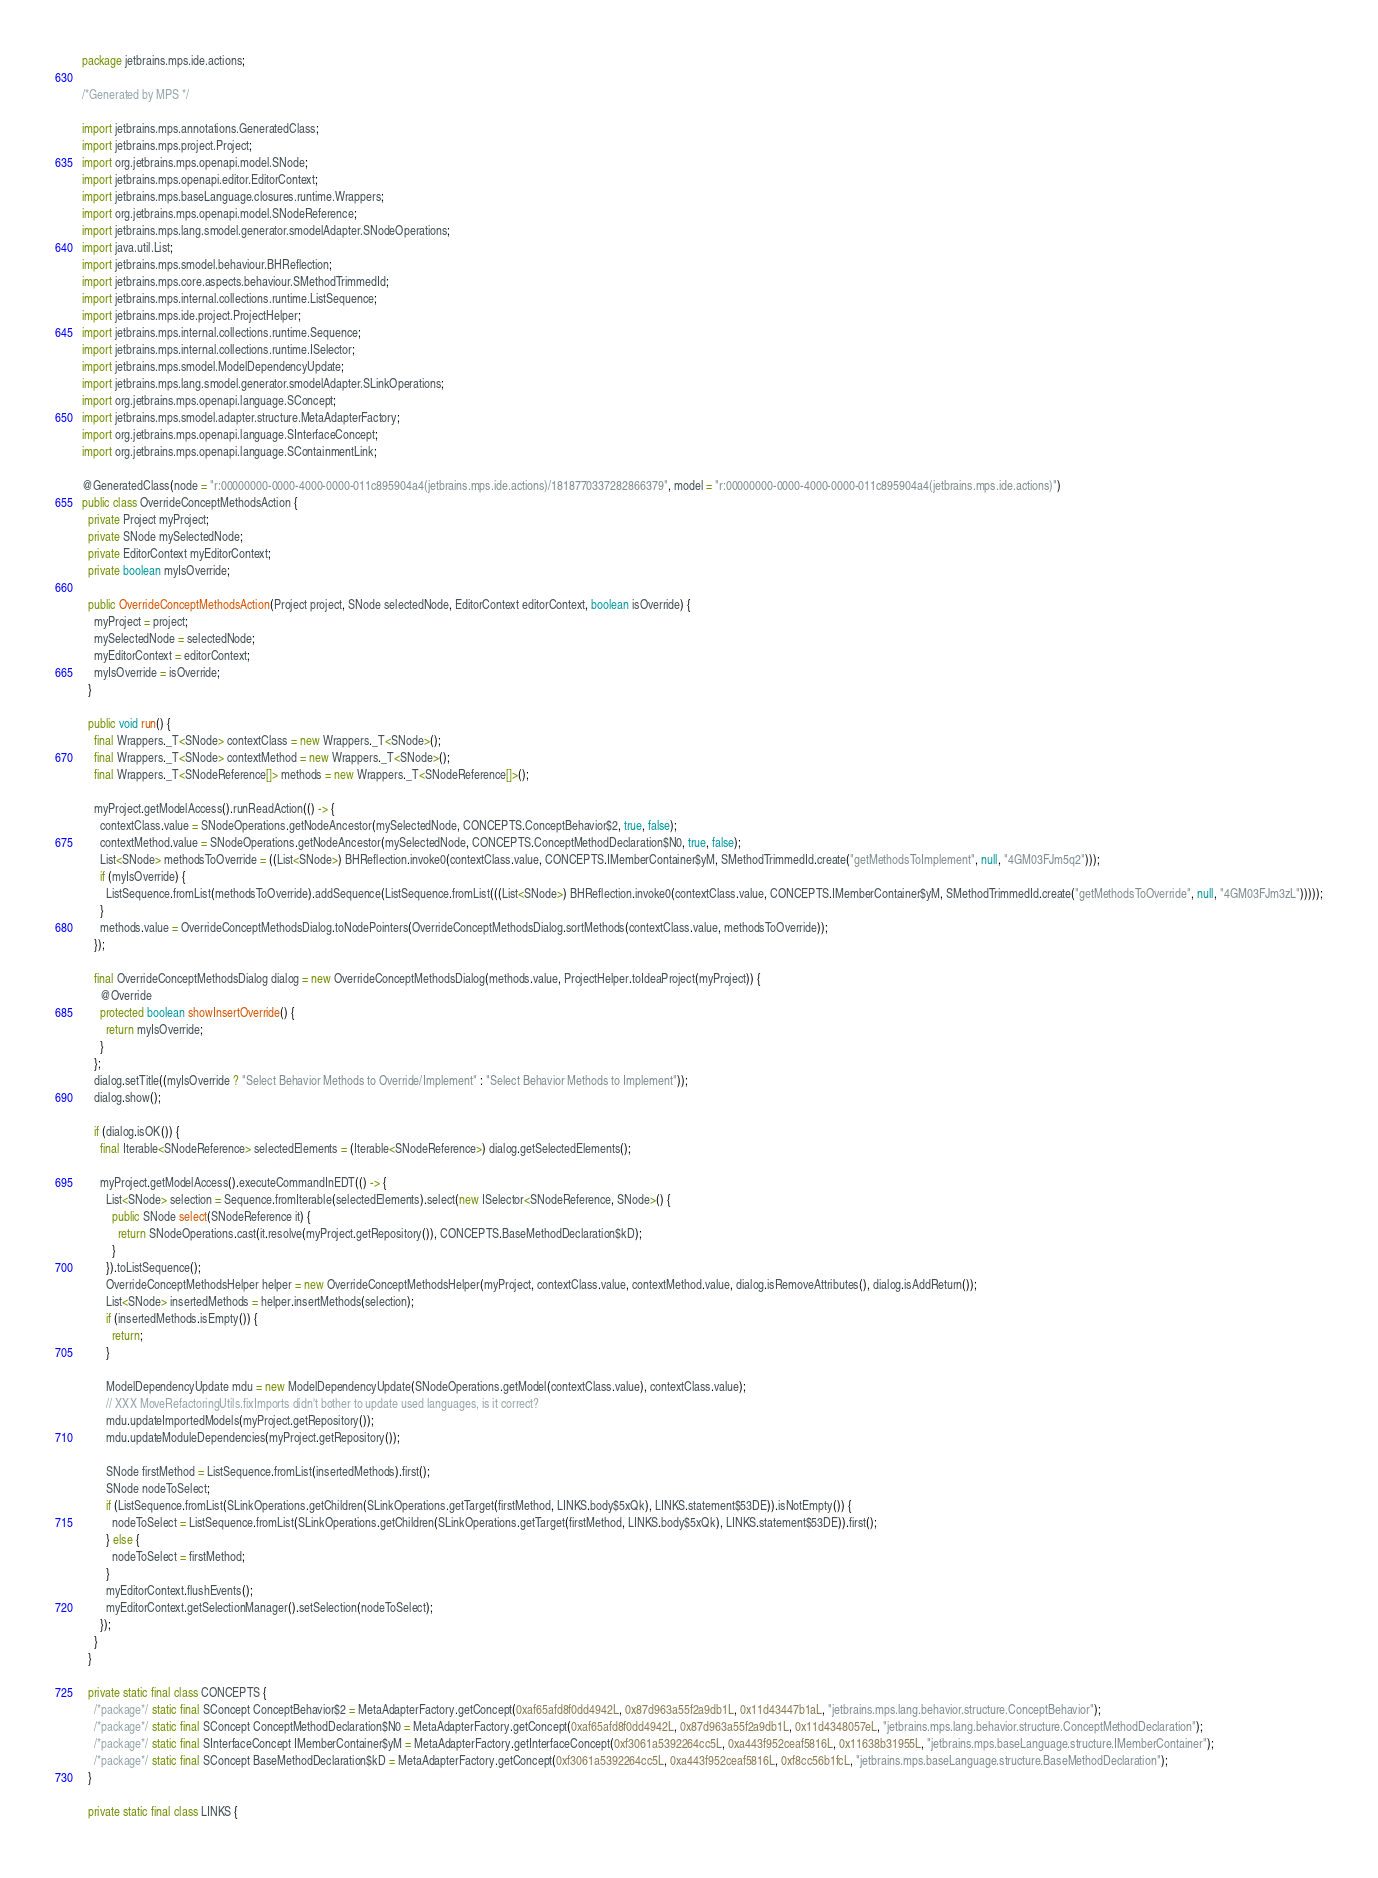Convert code to text. <code><loc_0><loc_0><loc_500><loc_500><_Java_>package jetbrains.mps.ide.actions;

/*Generated by MPS */

import jetbrains.mps.annotations.GeneratedClass;
import jetbrains.mps.project.Project;
import org.jetbrains.mps.openapi.model.SNode;
import jetbrains.mps.openapi.editor.EditorContext;
import jetbrains.mps.baseLanguage.closures.runtime.Wrappers;
import org.jetbrains.mps.openapi.model.SNodeReference;
import jetbrains.mps.lang.smodel.generator.smodelAdapter.SNodeOperations;
import java.util.List;
import jetbrains.mps.smodel.behaviour.BHReflection;
import jetbrains.mps.core.aspects.behaviour.SMethodTrimmedId;
import jetbrains.mps.internal.collections.runtime.ListSequence;
import jetbrains.mps.ide.project.ProjectHelper;
import jetbrains.mps.internal.collections.runtime.Sequence;
import jetbrains.mps.internal.collections.runtime.ISelector;
import jetbrains.mps.smodel.ModelDependencyUpdate;
import jetbrains.mps.lang.smodel.generator.smodelAdapter.SLinkOperations;
import org.jetbrains.mps.openapi.language.SConcept;
import jetbrains.mps.smodel.adapter.structure.MetaAdapterFactory;
import org.jetbrains.mps.openapi.language.SInterfaceConcept;
import org.jetbrains.mps.openapi.language.SContainmentLink;

@GeneratedClass(node = "r:00000000-0000-4000-0000-011c895904a4(jetbrains.mps.ide.actions)/1818770337282866379", model = "r:00000000-0000-4000-0000-011c895904a4(jetbrains.mps.ide.actions)")
public class OverrideConceptMethodsAction {
  private Project myProject;
  private SNode mySelectedNode;
  private EditorContext myEditorContext;
  private boolean myIsOverride;

  public OverrideConceptMethodsAction(Project project, SNode selectedNode, EditorContext editorContext, boolean isOverride) {
    myProject = project;
    mySelectedNode = selectedNode;
    myEditorContext = editorContext;
    myIsOverride = isOverride;
  }

  public void run() {
    final Wrappers._T<SNode> contextClass = new Wrappers._T<SNode>();
    final Wrappers._T<SNode> contextMethod = new Wrappers._T<SNode>();
    final Wrappers._T<SNodeReference[]> methods = new Wrappers._T<SNodeReference[]>();

    myProject.getModelAccess().runReadAction(() -> {
      contextClass.value = SNodeOperations.getNodeAncestor(mySelectedNode, CONCEPTS.ConceptBehavior$2, true, false);
      contextMethod.value = SNodeOperations.getNodeAncestor(mySelectedNode, CONCEPTS.ConceptMethodDeclaration$N0, true, false);
      List<SNode> methodsToOverride = ((List<SNode>) BHReflection.invoke0(contextClass.value, CONCEPTS.IMemberContainer$yM, SMethodTrimmedId.create("getMethodsToImplement", null, "4GM03FJm5q2")));
      if (myIsOverride) {
        ListSequence.fromList(methodsToOverride).addSequence(ListSequence.fromList(((List<SNode>) BHReflection.invoke0(contextClass.value, CONCEPTS.IMemberContainer$yM, SMethodTrimmedId.create("getMethodsToOverride", null, "4GM03FJm3zL")))));
      }
      methods.value = OverrideConceptMethodsDialog.toNodePointers(OverrideConceptMethodsDialog.sortMethods(contextClass.value, methodsToOverride));
    });

    final OverrideConceptMethodsDialog dialog = new OverrideConceptMethodsDialog(methods.value, ProjectHelper.toIdeaProject(myProject)) {
      @Override
      protected boolean showInsertOverride() {
        return myIsOverride;
      }
    };
    dialog.setTitle((myIsOverride ? "Select Behavior Methods to Override/Implement" : "Select Behavior Methods to Implement"));
    dialog.show();

    if (dialog.isOK()) {
      final Iterable<SNodeReference> selectedElements = (Iterable<SNodeReference>) dialog.getSelectedElements();

      myProject.getModelAccess().executeCommandInEDT(() -> {
        List<SNode> selection = Sequence.fromIterable(selectedElements).select(new ISelector<SNodeReference, SNode>() {
          public SNode select(SNodeReference it) {
            return SNodeOperations.cast(it.resolve(myProject.getRepository()), CONCEPTS.BaseMethodDeclaration$kD);
          }
        }).toListSequence();
        OverrideConceptMethodsHelper helper = new OverrideConceptMethodsHelper(myProject, contextClass.value, contextMethod.value, dialog.isRemoveAttributes(), dialog.isAddReturn());
        List<SNode> insertedMethods = helper.insertMethods(selection);
        if (insertedMethods.isEmpty()) {
          return;
        }

        ModelDependencyUpdate mdu = new ModelDependencyUpdate(SNodeOperations.getModel(contextClass.value), contextClass.value);
        // XXX MoveRefactoringUtils.fixImports didn't bother to update used languages, is it correct?
        mdu.updateImportedModels(myProject.getRepository());
        mdu.updateModuleDependencies(myProject.getRepository());

        SNode firstMethod = ListSequence.fromList(insertedMethods).first();
        SNode nodeToSelect;
        if (ListSequence.fromList(SLinkOperations.getChildren(SLinkOperations.getTarget(firstMethod, LINKS.body$5xQk), LINKS.statement$53DE)).isNotEmpty()) {
          nodeToSelect = ListSequence.fromList(SLinkOperations.getChildren(SLinkOperations.getTarget(firstMethod, LINKS.body$5xQk), LINKS.statement$53DE)).first();
        } else {
          nodeToSelect = firstMethod;
        }
        myEditorContext.flushEvents();
        myEditorContext.getSelectionManager().setSelection(nodeToSelect);
      });
    }
  }

  private static final class CONCEPTS {
    /*package*/ static final SConcept ConceptBehavior$2 = MetaAdapterFactory.getConcept(0xaf65afd8f0dd4942L, 0x87d963a55f2a9db1L, 0x11d43447b1aL, "jetbrains.mps.lang.behavior.structure.ConceptBehavior");
    /*package*/ static final SConcept ConceptMethodDeclaration$N0 = MetaAdapterFactory.getConcept(0xaf65afd8f0dd4942L, 0x87d963a55f2a9db1L, 0x11d4348057eL, "jetbrains.mps.lang.behavior.structure.ConceptMethodDeclaration");
    /*package*/ static final SInterfaceConcept IMemberContainer$yM = MetaAdapterFactory.getInterfaceConcept(0xf3061a5392264cc5L, 0xa443f952ceaf5816L, 0x11638b31955L, "jetbrains.mps.baseLanguage.structure.IMemberContainer");
    /*package*/ static final SConcept BaseMethodDeclaration$kD = MetaAdapterFactory.getConcept(0xf3061a5392264cc5L, 0xa443f952ceaf5816L, 0xf8cc56b1fcL, "jetbrains.mps.baseLanguage.structure.BaseMethodDeclaration");
  }

  private static final class LINKS {</code> 